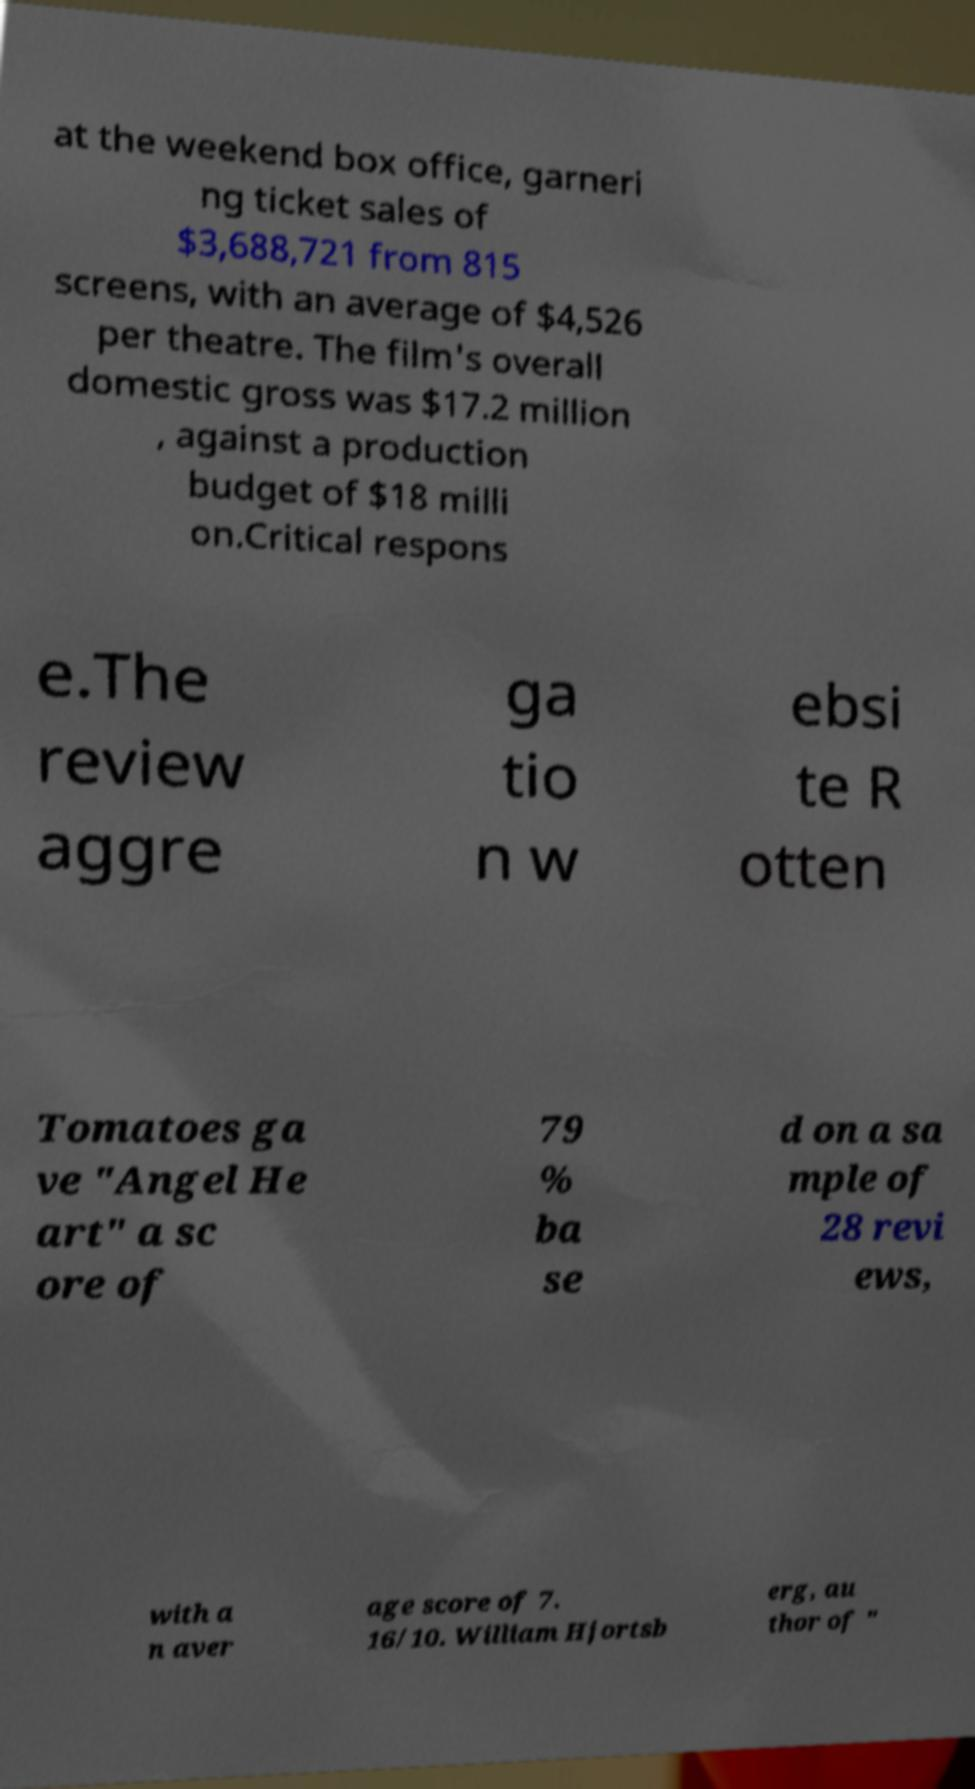Please read and relay the text visible in this image. What does it say? at the weekend box office, garneri ng ticket sales of $3,688,721 from 815 screens, with an average of $4,526 per theatre. The film's overall domestic gross was $17.2 million , against a production budget of $18 milli on.Critical respons e.The review aggre ga tio n w ebsi te R otten Tomatoes ga ve "Angel He art" a sc ore of 79 % ba se d on a sa mple of 28 revi ews, with a n aver age score of 7. 16/10. William Hjortsb erg, au thor of " 